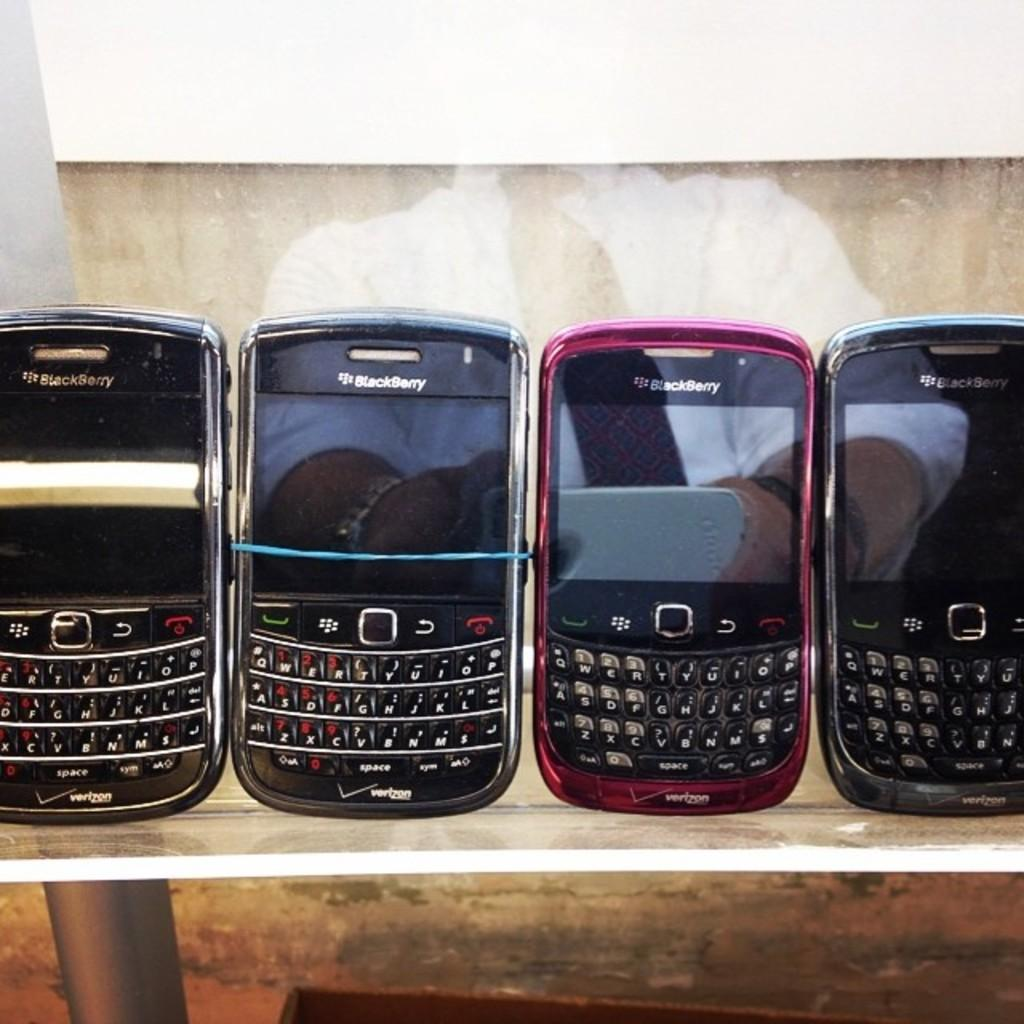How many mobiles are visible in the image? There are four mobiles in the image. What else can be seen in the image besides the mobiles? There is a reflection of a man in the image. What is the man holding in the image? The man is holding a phone. How is the man dressed in the image? The man is wearing a white shirt and tie. What type of scarecrow can be seen playing volleyball in the image? There is no scarecrow or volleyball present in the image. What effect does the man's presence have on the mobiles in the image? The man's presence does not have any direct effect on the mobiles in the image; they are separate subjects. 